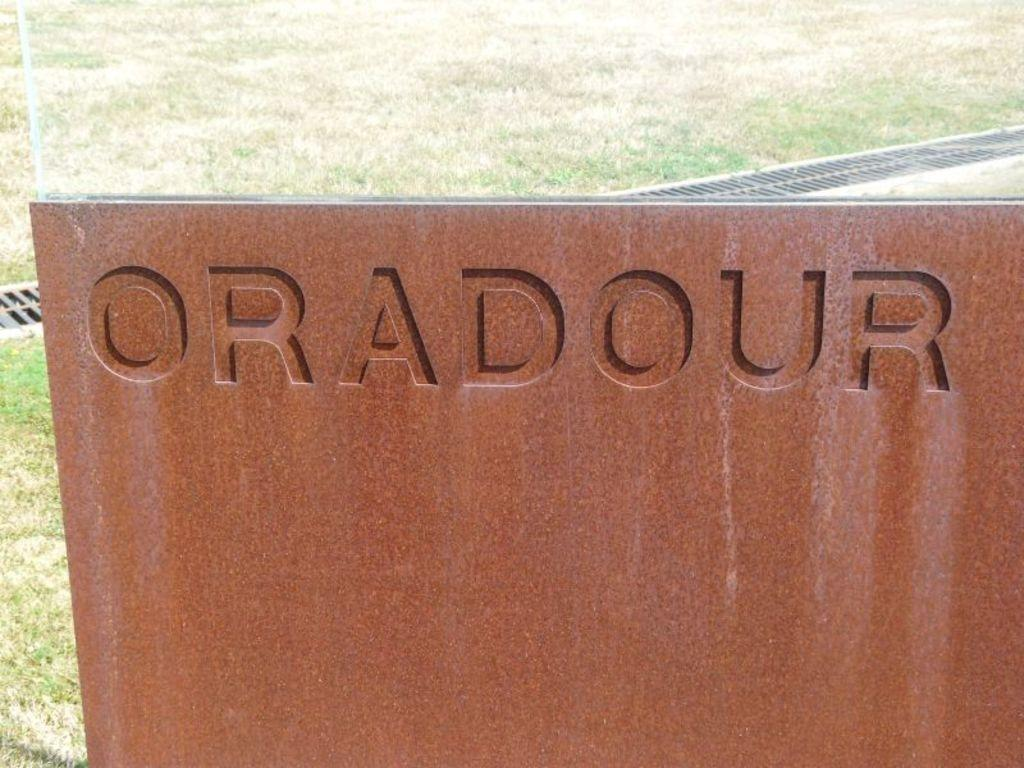Where was the image taken? The image was taken outdoors. What can be seen in the middle of the image? There is a board with text in the middle of the image. What type of surface is visible in the background of the image? There is a ground with grass in the background of the image. How many birds are standing on the board in the image? There are no birds present on the board or in the image. 